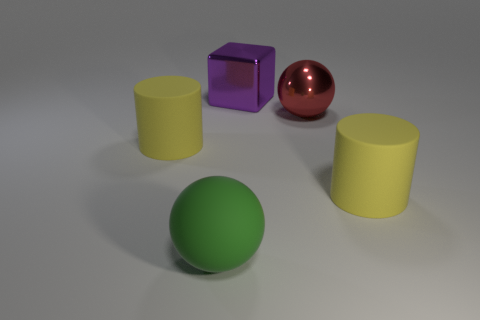Does the big purple thing have the same shape as the large red metal thing?
Your response must be concise. No. How many large things are either purple blocks or red objects?
Give a very brief answer. 2. Is the number of metal objects greater than the number of gray matte objects?
Keep it short and to the point. Yes. What is the size of the red sphere that is the same material as the purple thing?
Give a very brief answer. Large. Do the object on the left side of the green rubber object and the matte ball in front of the large red metallic sphere have the same size?
Your response must be concise. Yes. How many things are either yellow cylinders on the left side of the green object or big yellow rubber cylinders?
Your response must be concise. 2. Is the number of blue metal cylinders less than the number of shiny objects?
Give a very brief answer. Yes. What shape is the rubber thing on the right side of the metallic object that is behind the large ball right of the rubber sphere?
Offer a very short reply. Cylinder. Is there a big metal object?
Your response must be concise. Yes. There is a purple cube; is it the same size as the sphere that is behind the large green sphere?
Provide a short and direct response. Yes. 